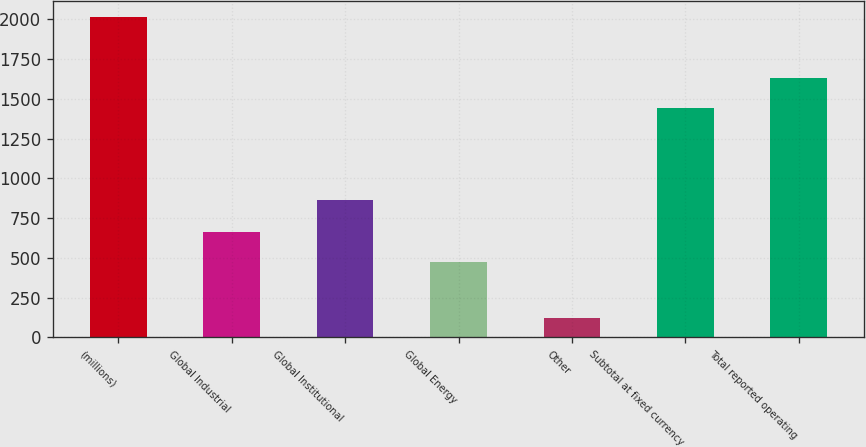Convert chart to OTSL. <chart><loc_0><loc_0><loc_500><loc_500><bar_chart><fcel>(millions)<fcel>Global Industrial<fcel>Global Institutional<fcel>Global Energy<fcel>Other<fcel>Subtotal at fixed currency<fcel>Total reported operating<nl><fcel>2015<fcel>664.34<fcel>867.1<fcel>475.3<fcel>124.6<fcel>1441.5<fcel>1630.54<nl></chart> 